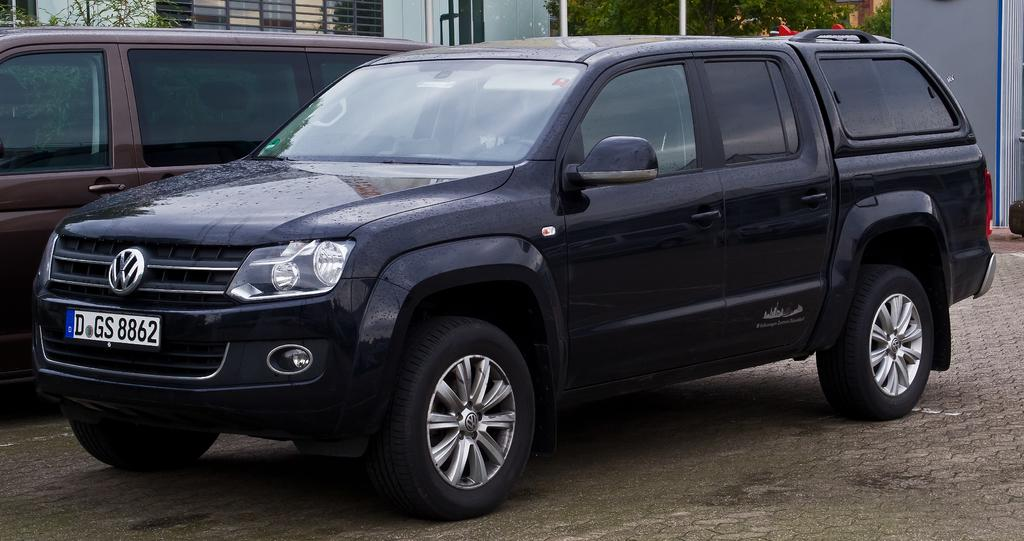What type of view is shown in the image? The image is an outside view. What vehicles are present in the image? There are two cars on the ground. What can be seen in the background of the image? There is a building and trees in the background. What type of paper is being used to fly the kite in the image? There is no kite present in the image, so it is not possible to determine what type of paper might be used. 